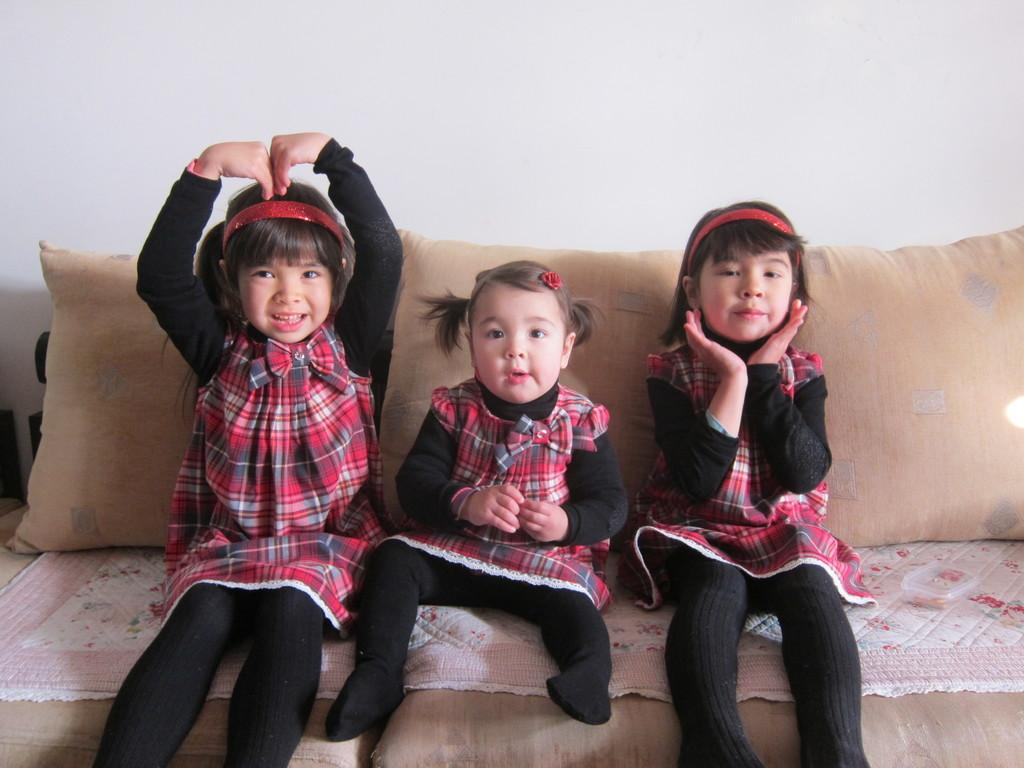How many people are in the image? There are three girls in the image. What are the girls doing in the image? The girls are sitting on a sofa. What can be found on the sofa? There are cushions on the sofa. What is visible in the background of the image? There is a wall in the background of the image. What type of steel structure can be seen in the image? There is no steel structure present in the image; it features three girls sitting on a sofa with cushions and a wall in the background. 